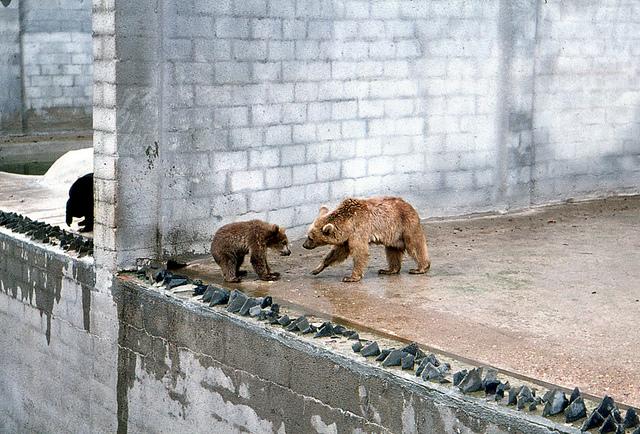What is along the edge of the wall?
Keep it brief. Rocks. What are the bears doing?
Answer briefly. Playing. Is the area dry?
Be succinct. No. 